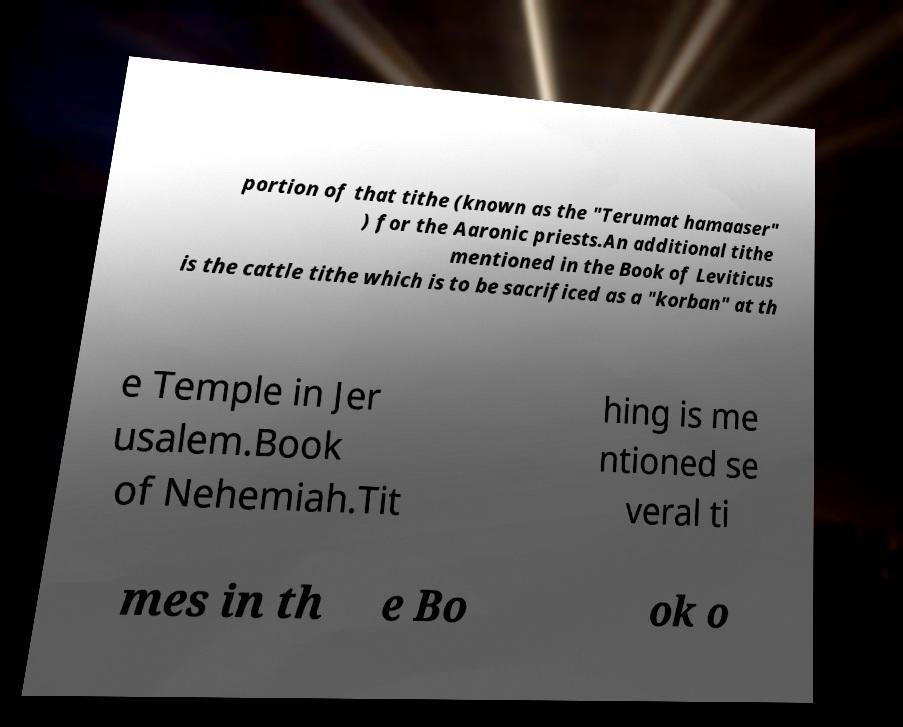Could you assist in decoding the text presented in this image and type it out clearly? portion of that tithe (known as the "Terumat hamaaser" ) for the Aaronic priests.An additional tithe mentioned in the Book of Leviticus is the cattle tithe which is to be sacrificed as a "korban" at th e Temple in Jer usalem.Book of Nehemiah.Tit hing is me ntioned se veral ti mes in th e Bo ok o 